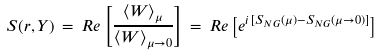<formula> <loc_0><loc_0><loc_500><loc_500>S ( r , Y ) \, = \, R e \left [ \frac { \langle W \rangle _ { \mu } } { \langle W \rangle _ { \mu \rightarrow 0 } } \right ] \, = \, R e \left [ e ^ { i \, [ S _ { N G } ( \mu ) - S _ { N G } ( \mu \rightarrow 0 ) ] } \right ]</formula> 